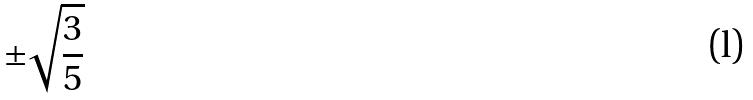Convert formula to latex. <formula><loc_0><loc_0><loc_500><loc_500>\pm \sqrt { \frac { 3 } { 5 } }</formula> 